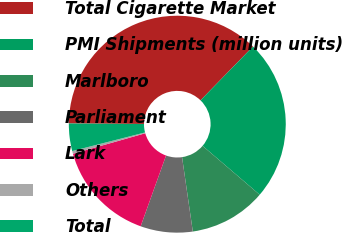Convert chart. <chart><loc_0><loc_0><loc_500><loc_500><pie_chart><fcel>Total Cigarette Market<fcel>PMI Shipments (million units)<fcel>Marlboro<fcel>Parliament<fcel>Lark<fcel>Others<fcel>Total<nl><fcel>37.19%<fcel>23.97%<fcel>11.45%<fcel>7.77%<fcel>15.12%<fcel>0.41%<fcel>4.09%<nl></chart> 